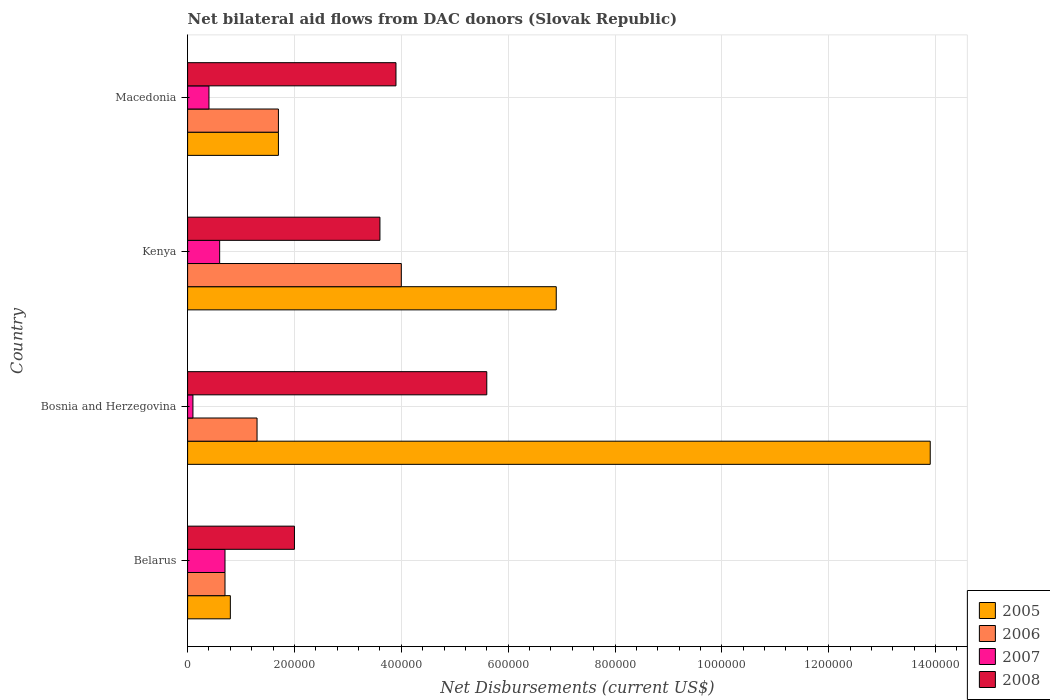How many different coloured bars are there?
Your answer should be compact. 4. How many groups of bars are there?
Provide a short and direct response. 4. Are the number of bars on each tick of the Y-axis equal?
Your answer should be very brief. Yes. What is the label of the 2nd group of bars from the top?
Offer a terse response. Kenya. What is the net bilateral aid flows in 2006 in Belarus?
Keep it short and to the point. 7.00e+04. Across all countries, what is the maximum net bilateral aid flows in 2008?
Offer a very short reply. 5.60e+05. In which country was the net bilateral aid flows in 2006 maximum?
Your response must be concise. Kenya. In which country was the net bilateral aid flows in 2006 minimum?
Make the answer very short. Belarus. What is the total net bilateral aid flows in 2008 in the graph?
Provide a short and direct response. 1.51e+06. What is the difference between the net bilateral aid flows in 2005 in Kenya and that in Macedonia?
Provide a succinct answer. 5.20e+05. What is the difference between the net bilateral aid flows in 2005 in Belarus and the net bilateral aid flows in 2008 in Bosnia and Herzegovina?
Make the answer very short. -4.80e+05. What is the average net bilateral aid flows in 2006 per country?
Keep it short and to the point. 1.92e+05. What is the difference between the net bilateral aid flows in 2008 and net bilateral aid flows in 2006 in Belarus?
Give a very brief answer. 1.30e+05. What is the ratio of the net bilateral aid flows in 2008 in Belarus to that in Kenya?
Your response must be concise. 0.56. Is the net bilateral aid flows in 2005 in Belarus less than that in Bosnia and Herzegovina?
Provide a short and direct response. Yes. What is the difference between the highest and the second highest net bilateral aid flows in 2006?
Ensure brevity in your answer.  2.30e+05. What is the difference between the highest and the lowest net bilateral aid flows in 2008?
Provide a short and direct response. 3.60e+05. Is it the case that in every country, the sum of the net bilateral aid flows in 2007 and net bilateral aid flows in 2008 is greater than the sum of net bilateral aid flows in 2006 and net bilateral aid flows in 2005?
Your answer should be compact. Yes. What does the 3rd bar from the top in Bosnia and Herzegovina represents?
Your answer should be compact. 2006. How many bars are there?
Provide a succinct answer. 16. How many countries are there in the graph?
Your response must be concise. 4. What is the difference between two consecutive major ticks on the X-axis?
Give a very brief answer. 2.00e+05. Are the values on the major ticks of X-axis written in scientific E-notation?
Make the answer very short. No. What is the title of the graph?
Give a very brief answer. Net bilateral aid flows from DAC donors (Slovak Republic). What is the label or title of the X-axis?
Give a very brief answer. Net Disbursements (current US$). What is the label or title of the Y-axis?
Offer a very short reply. Country. What is the Net Disbursements (current US$) in 2005 in Belarus?
Offer a very short reply. 8.00e+04. What is the Net Disbursements (current US$) in 2007 in Belarus?
Offer a terse response. 7.00e+04. What is the Net Disbursements (current US$) of 2005 in Bosnia and Herzegovina?
Your response must be concise. 1.39e+06. What is the Net Disbursements (current US$) of 2007 in Bosnia and Herzegovina?
Give a very brief answer. 10000. What is the Net Disbursements (current US$) in 2008 in Bosnia and Herzegovina?
Make the answer very short. 5.60e+05. What is the Net Disbursements (current US$) of 2005 in Kenya?
Offer a terse response. 6.90e+05. What is the Net Disbursements (current US$) of 2006 in Macedonia?
Offer a terse response. 1.70e+05. What is the Net Disbursements (current US$) of 2008 in Macedonia?
Keep it short and to the point. 3.90e+05. Across all countries, what is the maximum Net Disbursements (current US$) of 2005?
Give a very brief answer. 1.39e+06. Across all countries, what is the maximum Net Disbursements (current US$) of 2006?
Make the answer very short. 4.00e+05. Across all countries, what is the maximum Net Disbursements (current US$) of 2007?
Make the answer very short. 7.00e+04. Across all countries, what is the maximum Net Disbursements (current US$) in 2008?
Your answer should be compact. 5.60e+05. Across all countries, what is the minimum Net Disbursements (current US$) of 2006?
Make the answer very short. 7.00e+04. Across all countries, what is the minimum Net Disbursements (current US$) of 2007?
Offer a terse response. 10000. What is the total Net Disbursements (current US$) in 2005 in the graph?
Your answer should be compact. 2.33e+06. What is the total Net Disbursements (current US$) in 2006 in the graph?
Your answer should be compact. 7.70e+05. What is the total Net Disbursements (current US$) in 2007 in the graph?
Your response must be concise. 1.80e+05. What is the total Net Disbursements (current US$) of 2008 in the graph?
Your answer should be very brief. 1.51e+06. What is the difference between the Net Disbursements (current US$) of 2005 in Belarus and that in Bosnia and Herzegovina?
Keep it short and to the point. -1.31e+06. What is the difference between the Net Disbursements (current US$) of 2006 in Belarus and that in Bosnia and Herzegovina?
Offer a terse response. -6.00e+04. What is the difference between the Net Disbursements (current US$) of 2008 in Belarus and that in Bosnia and Herzegovina?
Your response must be concise. -3.60e+05. What is the difference between the Net Disbursements (current US$) in 2005 in Belarus and that in Kenya?
Offer a very short reply. -6.10e+05. What is the difference between the Net Disbursements (current US$) of 2006 in Belarus and that in Kenya?
Provide a succinct answer. -3.30e+05. What is the difference between the Net Disbursements (current US$) in 2005 in Belarus and that in Macedonia?
Make the answer very short. -9.00e+04. What is the difference between the Net Disbursements (current US$) in 2007 in Belarus and that in Macedonia?
Offer a very short reply. 3.00e+04. What is the difference between the Net Disbursements (current US$) of 2008 in Belarus and that in Macedonia?
Your answer should be very brief. -1.90e+05. What is the difference between the Net Disbursements (current US$) of 2005 in Bosnia and Herzegovina and that in Kenya?
Your answer should be compact. 7.00e+05. What is the difference between the Net Disbursements (current US$) of 2006 in Bosnia and Herzegovina and that in Kenya?
Your answer should be compact. -2.70e+05. What is the difference between the Net Disbursements (current US$) of 2005 in Bosnia and Herzegovina and that in Macedonia?
Keep it short and to the point. 1.22e+06. What is the difference between the Net Disbursements (current US$) of 2007 in Bosnia and Herzegovina and that in Macedonia?
Provide a succinct answer. -3.00e+04. What is the difference between the Net Disbursements (current US$) in 2008 in Bosnia and Herzegovina and that in Macedonia?
Your response must be concise. 1.70e+05. What is the difference between the Net Disbursements (current US$) of 2005 in Kenya and that in Macedonia?
Your response must be concise. 5.20e+05. What is the difference between the Net Disbursements (current US$) of 2006 in Kenya and that in Macedonia?
Ensure brevity in your answer.  2.30e+05. What is the difference between the Net Disbursements (current US$) of 2007 in Kenya and that in Macedonia?
Your answer should be very brief. 2.00e+04. What is the difference between the Net Disbursements (current US$) in 2008 in Kenya and that in Macedonia?
Offer a terse response. -3.00e+04. What is the difference between the Net Disbursements (current US$) in 2005 in Belarus and the Net Disbursements (current US$) in 2007 in Bosnia and Herzegovina?
Provide a succinct answer. 7.00e+04. What is the difference between the Net Disbursements (current US$) of 2005 in Belarus and the Net Disbursements (current US$) of 2008 in Bosnia and Herzegovina?
Offer a very short reply. -4.80e+05. What is the difference between the Net Disbursements (current US$) in 2006 in Belarus and the Net Disbursements (current US$) in 2007 in Bosnia and Herzegovina?
Provide a succinct answer. 6.00e+04. What is the difference between the Net Disbursements (current US$) of 2006 in Belarus and the Net Disbursements (current US$) of 2008 in Bosnia and Herzegovina?
Offer a terse response. -4.90e+05. What is the difference between the Net Disbursements (current US$) in 2007 in Belarus and the Net Disbursements (current US$) in 2008 in Bosnia and Herzegovina?
Your answer should be very brief. -4.90e+05. What is the difference between the Net Disbursements (current US$) in 2005 in Belarus and the Net Disbursements (current US$) in 2006 in Kenya?
Make the answer very short. -3.20e+05. What is the difference between the Net Disbursements (current US$) of 2005 in Belarus and the Net Disbursements (current US$) of 2007 in Kenya?
Provide a succinct answer. 2.00e+04. What is the difference between the Net Disbursements (current US$) of 2005 in Belarus and the Net Disbursements (current US$) of 2008 in Kenya?
Your answer should be very brief. -2.80e+05. What is the difference between the Net Disbursements (current US$) of 2007 in Belarus and the Net Disbursements (current US$) of 2008 in Kenya?
Provide a short and direct response. -2.90e+05. What is the difference between the Net Disbursements (current US$) of 2005 in Belarus and the Net Disbursements (current US$) of 2006 in Macedonia?
Your answer should be very brief. -9.00e+04. What is the difference between the Net Disbursements (current US$) in 2005 in Belarus and the Net Disbursements (current US$) in 2008 in Macedonia?
Offer a very short reply. -3.10e+05. What is the difference between the Net Disbursements (current US$) of 2006 in Belarus and the Net Disbursements (current US$) of 2008 in Macedonia?
Provide a succinct answer. -3.20e+05. What is the difference between the Net Disbursements (current US$) of 2007 in Belarus and the Net Disbursements (current US$) of 2008 in Macedonia?
Your response must be concise. -3.20e+05. What is the difference between the Net Disbursements (current US$) of 2005 in Bosnia and Herzegovina and the Net Disbursements (current US$) of 2006 in Kenya?
Keep it short and to the point. 9.90e+05. What is the difference between the Net Disbursements (current US$) of 2005 in Bosnia and Herzegovina and the Net Disbursements (current US$) of 2007 in Kenya?
Your response must be concise. 1.33e+06. What is the difference between the Net Disbursements (current US$) in 2005 in Bosnia and Herzegovina and the Net Disbursements (current US$) in 2008 in Kenya?
Your answer should be very brief. 1.03e+06. What is the difference between the Net Disbursements (current US$) in 2007 in Bosnia and Herzegovina and the Net Disbursements (current US$) in 2008 in Kenya?
Offer a terse response. -3.50e+05. What is the difference between the Net Disbursements (current US$) of 2005 in Bosnia and Herzegovina and the Net Disbursements (current US$) of 2006 in Macedonia?
Your answer should be compact. 1.22e+06. What is the difference between the Net Disbursements (current US$) of 2005 in Bosnia and Herzegovina and the Net Disbursements (current US$) of 2007 in Macedonia?
Ensure brevity in your answer.  1.35e+06. What is the difference between the Net Disbursements (current US$) in 2005 in Bosnia and Herzegovina and the Net Disbursements (current US$) in 2008 in Macedonia?
Provide a succinct answer. 1.00e+06. What is the difference between the Net Disbursements (current US$) of 2007 in Bosnia and Herzegovina and the Net Disbursements (current US$) of 2008 in Macedonia?
Keep it short and to the point. -3.80e+05. What is the difference between the Net Disbursements (current US$) in 2005 in Kenya and the Net Disbursements (current US$) in 2006 in Macedonia?
Provide a short and direct response. 5.20e+05. What is the difference between the Net Disbursements (current US$) of 2005 in Kenya and the Net Disbursements (current US$) of 2007 in Macedonia?
Ensure brevity in your answer.  6.50e+05. What is the difference between the Net Disbursements (current US$) in 2006 in Kenya and the Net Disbursements (current US$) in 2008 in Macedonia?
Make the answer very short. 10000. What is the difference between the Net Disbursements (current US$) in 2007 in Kenya and the Net Disbursements (current US$) in 2008 in Macedonia?
Provide a short and direct response. -3.30e+05. What is the average Net Disbursements (current US$) in 2005 per country?
Offer a very short reply. 5.82e+05. What is the average Net Disbursements (current US$) of 2006 per country?
Offer a terse response. 1.92e+05. What is the average Net Disbursements (current US$) of 2007 per country?
Offer a very short reply. 4.50e+04. What is the average Net Disbursements (current US$) of 2008 per country?
Offer a terse response. 3.78e+05. What is the difference between the Net Disbursements (current US$) in 2005 and Net Disbursements (current US$) in 2006 in Belarus?
Provide a succinct answer. 10000. What is the difference between the Net Disbursements (current US$) of 2006 and Net Disbursements (current US$) of 2007 in Belarus?
Make the answer very short. 0. What is the difference between the Net Disbursements (current US$) of 2006 and Net Disbursements (current US$) of 2008 in Belarus?
Ensure brevity in your answer.  -1.30e+05. What is the difference between the Net Disbursements (current US$) of 2005 and Net Disbursements (current US$) of 2006 in Bosnia and Herzegovina?
Your answer should be compact. 1.26e+06. What is the difference between the Net Disbursements (current US$) of 2005 and Net Disbursements (current US$) of 2007 in Bosnia and Herzegovina?
Keep it short and to the point. 1.38e+06. What is the difference between the Net Disbursements (current US$) of 2005 and Net Disbursements (current US$) of 2008 in Bosnia and Herzegovina?
Offer a very short reply. 8.30e+05. What is the difference between the Net Disbursements (current US$) in 2006 and Net Disbursements (current US$) in 2008 in Bosnia and Herzegovina?
Your response must be concise. -4.30e+05. What is the difference between the Net Disbursements (current US$) of 2007 and Net Disbursements (current US$) of 2008 in Bosnia and Herzegovina?
Provide a short and direct response. -5.50e+05. What is the difference between the Net Disbursements (current US$) in 2005 and Net Disbursements (current US$) in 2007 in Kenya?
Provide a short and direct response. 6.30e+05. What is the difference between the Net Disbursements (current US$) of 2006 and Net Disbursements (current US$) of 2007 in Kenya?
Your answer should be compact. 3.40e+05. What is the difference between the Net Disbursements (current US$) of 2007 and Net Disbursements (current US$) of 2008 in Kenya?
Offer a terse response. -3.00e+05. What is the difference between the Net Disbursements (current US$) in 2005 and Net Disbursements (current US$) in 2007 in Macedonia?
Provide a succinct answer. 1.30e+05. What is the difference between the Net Disbursements (current US$) of 2006 and Net Disbursements (current US$) of 2007 in Macedonia?
Make the answer very short. 1.30e+05. What is the difference between the Net Disbursements (current US$) in 2007 and Net Disbursements (current US$) in 2008 in Macedonia?
Your answer should be compact. -3.50e+05. What is the ratio of the Net Disbursements (current US$) in 2005 in Belarus to that in Bosnia and Herzegovina?
Provide a succinct answer. 0.06. What is the ratio of the Net Disbursements (current US$) in 2006 in Belarus to that in Bosnia and Herzegovina?
Give a very brief answer. 0.54. What is the ratio of the Net Disbursements (current US$) of 2007 in Belarus to that in Bosnia and Herzegovina?
Provide a short and direct response. 7. What is the ratio of the Net Disbursements (current US$) in 2008 in Belarus to that in Bosnia and Herzegovina?
Ensure brevity in your answer.  0.36. What is the ratio of the Net Disbursements (current US$) of 2005 in Belarus to that in Kenya?
Your response must be concise. 0.12. What is the ratio of the Net Disbursements (current US$) of 2006 in Belarus to that in Kenya?
Make the answer very short. 0.17. What is the ratio of the Net Disbursements (current US$) of 2008 in Belarus to that in Kenya?
Ensure brevity in your answer.  0.56. What is the ratio of the Net Disbursements (current US$) of 2005 in Belarus to that in Macedonia?
Provide a succinct answer. 0.47. What is the ratio of the Net Disbursements (current US$) in 2006 in Belarus to that in Macedonia?
Your response must be concise. 0.41. What is the ratio of the Net Disbursements (current US$) of 2008 in Belarus to that in Macedonia?
Give a very brief answer. 0.51. What is the ratio of the Net Disbursements (current US$) of 2005 in Bosnia and Herzegovina to that in Kenya?
Provide a succinct answer. 2.01. What is the ratio of the Net Disbursements (current US$) of 2006 in Bosnia and Herzegovina to that in Kenya?
Offer a terse response. 0.33. What is the ratio of the Net Disbursements (current US$) of 2007 in Bosnia and Herzegovina to that in Kenya?
Give a very brief answer. 0.17. What is the ratio of the Net Disbursements (current US$) of 2008 in Bosnia and Herzegovina to that in Kenya?
Your response must be concise. 1.56. What is the ratio of the Net Disbursements (current US$) of 2005 in Bosnia and Herzegovina to that in Macedonia?
Your answer should be very brief. 8.18. What is the ratio of the Net Disbursements (current US$) in 2006 in Bosnia and Herzegovina to that in Macedonia?
Give a very brief answer. 0.76. What is the ratio of the Net Disbursements (current US$) of 2007 in Bosnia and Herzegovina to that in Macedonia?
Offer a very short reply. 0.25. What is the ratio of the Net Disbursements (current US$) in 2008 in Bosnia and Herzegovina to that in Macedonia?
Your answer should be compact. 1.44. What is the ratio of the Net Disbursements (current US$) in 2005 in Kenya to that in Macedonia?
Give a very brief answer. 4.06. What is the ratio of the Net Disbursements (current US$) in 2006 in Kenya to that in Macedonia?
Keep it short and to the point. 2.35. What is the ratio of the Net Disbursements (current US$) in 2007 in Kenya to that in Macedonia?
Your answer should be compact. 1.5. What is the difference between the highest and the second highest Net Disbursements (current US$) in 2007?
Offer a very short reply. 10000. What is the difference between the highest and the second highest Net Disbursements (current US$) in 2008?
Your response must be concise. 1.70e+05. What is the difference between the highest and the lowest Net Disbursements (current US$) in 2005?
Ensure brevity in your answer.  1.31e+06. What is the difference between the highest and the lowest Net Disbursements (current US$) in 2006?
Offer a very short reply. 3.30e+05. What is the difference between the highest and the lowest Net Disbursements (current US$) in 2007?
Make the answer very short. 6.00e+04. What is the difference between the highest and the lowest Net Disbursements (current US$) in 2008?
Offer a very short reply. 3.60e+05. 